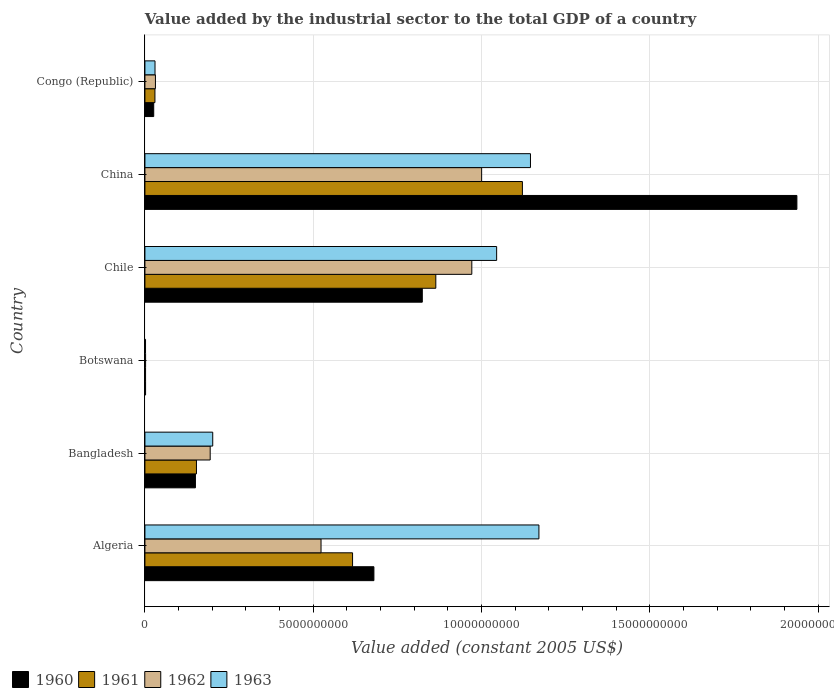How many groups of bars are there?
Provide a succinct answer. 6. Are the number of bars per tick equal to the number of legend labels?
Offer a terse response. Yes. How many bars are there on the 3rd tick from the bottom?
Ensure brevity in your answer.  4. What is the label of the 4th group of bars from the top?
Your answer should be very brief. Botswana. In how many cases, is the number of bars for a given country not equal to the number of legend labels?
Ensure brevity in your answer.  0. What is the value added by the industrial sector in 1962 in China?
Provide a succinct answer. 1.00e+1. Across all countries, what is the maximum value added by the industrial sector in 1962?
Keep it short and to the point. 1.00e+1. Across all countries, what is the minimum value added by the industrial sector in 1963?
Provide a succinct answer. 1.83e+07. In which country was the value added by the industrial sector in 1963 minimum?
Offer a terse response. Botswana. What is the total value added by the industrial sector in 1962 in the graph?
Your answer should be compact. 2.72e+1. What is the difference between the value added by the industrial sector in 1962 in Botswana and that in Chile?
Offer a very short reply. -9.69e+09. What is the difference between the value added by the industrial sector in 1961 in Bangladesh and the value added by the industrial sector in 1960 in Congo (Republic)?
Provide a succinct answer. 1.27e+09. What is the average value added by the industrial sector in 1961 per country?
Make the answer very short. 4.65e+09. What is the difference between the value added by the industrial sector in 1962 and value added by the industrial sector in 1961 in Chile?
Your response must be concise. 1.07e+09. In how many countries, is the value added by the industrial sector in 1961 greater than 15000000000 US$?
Give a very brief answer. 0. What is the ratio of the value added by the industrial sector in 1962 in Bangladesh to that in Congo (Republic)?
Provide a succinct answer. 6.21. Is the difference between the value added by the industrial sector in 1962 in Algeria and Bangladesh greater than the difference between the value added by the industrial sector in 1961 in Algeria and Bangladesh?
Offer a very short reply. No. What is the difference between the highest and the second highest value added by the industrial sector in 1963?
Your answer should be compact. 2.51e+08. What is the difference between the highest and the lowest value added by the industrial sector in 1963?
Ensure brevity in your answer.  1.17e+1. Is it the case that in every country, the sum of the value added by the industrial sector in 1961 and value added by the industrial sector in 1962 is greater than the sum of value added by the industrial sector in 1963 and value added by the industrial sector in 1960?
Your response must be concise. No. What does the 2nd bar from the top in Chile represents?
Give a very brief answer. 1962. Is it the case that in every country, the sum of the value added by the industrial sector in 1961 and value added by the industrial sector in 1960 is greater than the value added by the industrial sector in 1962?
Your response must be concise. Yes. How many bars are there?
Your answer should be very brief. 24. Are all the bars in the graph horizontal?
Keep it short and to the point. Yes. Does the graph contain any zero values?
Keep it short and to the point. No. Does the graph contain grids?
Your answer should be very brief. Yes. Where does the legend appear in the graph?
Give a very brief answer. Bottom left. What is the title of the graph?
Offer a terse response. Value added by the industrial sector to the total GDP of a country. What is the label or title of the X-axis?
Provide a succinct answer. Value added (constant 2005 US$). What is the label or title of the Y-axis?
Offer a terse response. Country. What is the Value added (constant 2005 US$) of 1960 in Algeria?
Provide a short and direct response. 6.80e+09. What is the Value added (constant 2005 US$) of 1961 in Algeria?
Your response must be concise. 6.17e+09. What is the Value added (constant 2005 US$) in 1962 in Algeria?
Provide a succinct answer. 5.23e+09. What is the Value added (constant 2005 US$) of 1963 in Algeria?
Your answer should be compact. 1.17e+1. What is the Value added (constant 2005 US$) of 1960 in Bangladesh?
Make the answer very short. 1.50e+09. What is the Value added (constant 2005 US$) of 1961 in Bangladesh?
Your answer should be very brief. 1.53e+09. What is the Value added (constant 2005 US$) of 1962 in Bangladesh?
Keep it short and to the point. 1.94e+09. What is the Value added (constant 2005 US$) in 1963 in Bangladesh?
Your answer should be compact. 2.01e+09. What is the Value added (constant 2005 US$) of 1960 in Botswana?
Keep it short and to the point. 1.96e+07. What is the Value added (constant 2005 US$) of 1961 in Botswana?
Your answer should be compact. 1.92e+07. What is the Value added (constant 2005 US$) of 1962 in Botswana?
Keep it short and to the point. 1.98e+07. What is the Value added (constant 2005 US$) of 1963 in Botswana?
Provide a short and direct response. 1.83e+07. What is the Value added (constant 2005 US$) of 1960 in Chile?
Give a very brief answer. 8.24e+09. What is the Value added (constant 2005 US$) in 1961 in Chile?
Your answer should be very brief. 8.64e+09. What is the Value added (constant 2005 US$) in 1962 in Chile?
Your response must be concise. 9.71e+09. What is the Value added (constant 2005 US$) in 1963 in Chile?
Your response must be concise. 1.04e+1. What is the Value added (constant 2005 US$) of 1960 in China?
Provide a short and direct response. 1.94e+1. What is the Value added (constant 2005 US$) of 1961 in China?
Your answer should be very brief. 1.12e+1. What is the Value added (constant 2005 US$) of 1962 in China?
Provide a succinct answer. 1.00e+1. What is the Value added (constant 2005 US$) in 1963 in China?
Make the answer very short. 1.15e+1. What is the Value added (constant 2005 US$) in 1960 in Congo (Republic)?
Ensure brevity in your answer.  2.61e+08. What is the Value added (constant 2005 US$) of 1961 in Congo (Republic)?
Offer a terse response. 2.98e+08. What is the Value added (constant 2005 US$) of 1962 in Congo (Republic)?
Your response must be concise. 3.12e+08. What is the Value added (constant 2005 US$) of 1963 in Congo (Republic)?
Give a very brief answer. 3.00e+08. Across all countries, what is the maximum Value added (constant 2005 US$) in 1960?
Provide a succinct answer. 1.94e+1. Across all countries, what is the maximum Value added (constant 2005 US$) of 1961?
Provide a short and direct response. 1.12e+1. Across all countries, what is the maximum Value added (constant 2005 US$) in 1962?
Your answer should be very brief. 1.00e+1. Across all countries, what is the maximum Value added (constant 2005 US$) of 1963?
Offer a terse response. 1.17e+1. Across all countries, what is the minimum Value added (constant 2005 US$) of 1960?
Your answer should be very brief. 1.96e+07. Across all countries, what is the minimum Value added (constant 2005 US$) of 1961?
Provide a short and direct response. 1.92e+07. Across all countries, what is the minimum Value added (constant 2005 US$) in 1962?
Your response must be concise. 1.98e+07. Across all countries, what is the minimum Value added (constant 2005 US$) in 1963?
Give a very brief answer. 1.83e+07. What is the total Value added (constant 2005 US$) in 1960 in the graph?
Keep it short and to the point. 3.62e+1. What is the total Value added (constant 2005 US$) in 1961 in the graph?
Offer a very short reply. 2.79e+1. What is the total Value added (constant 2005 US$) of 1962 in the graph?
Your response must be concise. 2.72e+1. What is the total Value added (constant 2005 US$) in 1963 in the graph?
Offer a terse response. 3.59e+1. What is the difference between the Value added (constant 2005 US$) of 1960 in Algeria and that in Bangladesh?
Give a very brief answer. 5.30e+09. What is the difference between the Value added (constant 2005 US$) of 1961 in Algeria and that in Bangladesh?
Your answer should be compact. 4.64e+09. What is the difference between the Value added (constant 2005 US$) of 1962 in Algeria and that in Bangladesh?
Make the answer very short. 3.29e+09. What is the difference between the Value added (constant 2005 US$) in 1963 in Algeria and that in Bangladesh?
Offer a very short reply. 9.69e+09. What is the difference between the Value added (constant 2005 US$) of 1960 in Algeria and that in Botswana?
Make the answer very short. 6.78e+09. What is the difference between the Value added (constant 2005 US$) of 1961 in Algeria and that in Botswana?
Offer a very short reply. 6.15e+09. What is the difference between the Value added (constant 2005 US$) of 1962 in Algeria and that in Botswana?
Give a very brief answer. 5.21e+09. What is the difference between the Value added (constant 2005 US$) in 1963 in Algeria and that in Botswana?
Provide a short and direct response. 1.17e+1. What is the difference between the Value added (constant 2005 US$) of 1960 in Algeria and that in Chile?
Provide a succinct answer. -1.44e+09. What is the difference between the Value added (constant 2005 US$) of 1961 in Algeria and that in Chile?
Keep it short and to the point. -2.47e+09. What is the difference between the Value added (constant 2005 US$) of 1962 in Algeria and that in Chile?
Ensure brevity in your answer.  -4.48e+09. What is the difference between the Value added (constant 2005 US$) in 1963 in Algeria and that in Chile?
Keep it short and to the point. 1.26e+09. What is the difference between the Value added (constant 2005 US$) in 1960 in Algeria and that in China?
Ensure brevity in your answer.  -1.26e+1. What is the difference between the Value added (constant 2005 US$) in 1961 in Algeria and that in China?
Your answer should be very brief. -5.05e+09. What is the difference between the Value added (constant 2005 US$) of 1962 in Algeria and that in China?
Make the answer very short. -4.77e+09. What is the difference between the Value added (constant 2005 US$) in 1963 in Algeria and that in China?
Offer a terse response. 2.51e+08. What is the difference between the Value added (constant 2005 US$) in 1960 in Algeria and that in Congo (Republic)?
Keep it short and to the point. 6.54e+09. What is the difference between the Value added (constant 2005 US$) in 1961 in Algeria and that in Congo (Republic)?
Your answer should be compact. 5.87e+09. What is the difference between the Value added (constant 2005 US$) of 1962 in Algeria and that in Congo (Republic)?
Make the answer very short. 4.92e+09. What is the difference between the Value added (constant 2005 US$) in 1963 in Algeria and that in Congo (Republic)?
Your answer should be very brief. 1.14e+1. What is the difference between the Value added (constant 2005 US$) of 1960 in Bangladesh and that in Botswana?
Give a very brief answer. 1.48e+09. What is the difference between the Value added (constant 2005 US$) of 1961 in Bangladesh and that in Botswana?
Provide a succinct answer. 1.51e+09. What is the difference between the Value added (constant 2005 US$) of 1962 in Bangladesh and that in Botswana?
Your answer should be very brief. 1.92e+09. What is the difference between the Value added (constant 2005 US$) of 1963 in Bangladesh and that in Botswana?
Provide a succinct answer. 2.00e+09. What is the difference between the Value added (constant 2005 US$) of 1960 in Bangladesh and that in Chile?
Your answer should be compact. -6.74e+09. What is the difference between the Value added (constant 2005 US$) in 1961 in Bangladesh and that in Chile?
Give a very brief answer. -7.11e+09. What is the difference between the Value added (constant 2005 US$) of 1962 in Bangladesh and that in Chile?
Give a very brief answer. -7.77e+09. What is the difference between the Value added (constant 2005 US$) in 1963 in Bangladesh and that in Chile?
Provide a short and direct response. -8.43e+09. What is the difference between the Value added (constant 2005 US$) in 1960 in Bangladesh and that in China?
Your answer should be very brief. -1.79e+1. What is the difference between the Value added (constant 2005 US$) in 1961 in Bangladesh and that in China?
Keep it short and to the point. -9.68e+09. What is the difference between the Value added (constant 2005 US$) of 1962 in Bangladesh and that in China?
Provide a succinct answer. -8.06e+09. What is the difference between the Value added (constant 2005 US$) in 1963 in Bangladesh and that in China?
Your answer should be compact. -9.44e+09. What is the difference between the Value added (constant 2005 US$) of 1960 in Bangladesh and that in Congo (Republic)?
Your answer should be very brief. 1.24e+09. What is the difference between the Value added (constant 2005 US$) in 1961 in Bangladesh and that in Congo (Republic)?
Your answer should be very brief. 1.23e+09. What is the difference between the Value added (constant 2005 US$) of 1962 in Bangladesh and that in Congo (Republic)?
Your answer should be very brief. 1.63e+09. What is the difference between the Value added (constant 2005 US$) in 1963 in Bangladesh and that in Congo (Republic)?
Give a very brief answer. 1.71e+09. What is the difference between the Value added (constant 2005 US$) of 1960 in Botswana and that in Chile?
Give a very brief answer. -8.22e+09. What is the difference between the Value added (constant 2005 US$) in 1961 in Botswana and that in Chile?
Your answer should be very brief. -8.62e+09. What is the difference between the Value added (constant 2005 US$) of 1962 in Botswana and that in Chile?
Offer a very short reply. -9.69e+09. What is the difference between the Value added (constant 2005 US$) of 1963 in Botswana and that in Chile?
Your response must be concise. -1.04e+1. What is the difference between the Value added (constant 2005 US$) of 1960 in Botswana and that in China?
Your response must be concise. -1.93e+1. What is the difference between the Value added (constant 2005 US$) of 1961 in Botswana and that in China?
Ensure brevity in your answer.  -1.12e+1. What is the difference between the Value added (constant 2005 US$) in 1962 in Botswana and that in China?
Keep it short and to the point. -9.98e+09. What is the difference between the Value added (constant 2005 US$) of 1963 in Botswana and that in China?
Provide a succinct answer. -1.14e+1. What is the difference between the Value added (constant 2005 US$) of 1960 in Botswana and that in Congo (Republic)?
Your answer should be very brief. -2.42e+08. What is the difference between the Value added (constant 2005 US$) of 1961 in Botswana and that in Congo (Republic)?
Your answer should be compact. -2.78e+08. What is the difference between the Value added (constant 2005 US$) in 1962 in Botswana and that in Congo (Republic)?
Provide a succinct answer. -2.93e+08. What is the difference between the Value added (constant 2005 US$) of 1963 in Botswana and that in Congo (Republic)?
Keep it short and to the point. -2.81e+08. What is the difference between the Value added (constant 2005 US$) of 1960 in Chile and that in China?
Ensure brevity in your answer.  -1.11e+1. What is the difference between the Value added (constant 2005 US$) of 1961 in Chile and that in China?
Offer a very short reply. -2.57e+09. What is the difference between the Value added (constant 2005 US$) in 1962 in Chile and that in China?
Your answer should be very brief. -2.92e+08. What is the difference between the Value added (constant 2005 US$) of 1963 in Chile and that in China?
Make the answer very short. -1.01e+09. What is the difference between the Value added (constant 2005 US$) in 1960 in Chile and that in Congo (Republic)?
Offer a very short reply. 7.98e+09. What is the difference between the Value added (constant 2005 US$) in 1961 in Chile and that in Congo (Republic)?
Give a very brief answer. 8.34e+09. What is the difference between the Value added (constant 2005 US$) in 1962 in Chile and that in Congo (Republic)?
Make the answer very short. 9.40e+09. What is the difference between the Value added (constant 2005 US$) of 1963 in Chile and that in Congo (Republic)?
Provide a short and direct response. 1.01e+1. What is the difference between the Value added (constant 2005 US$) of 1960 in China and that in Congo (Republic)?
Offer a very short reply. 1.91e+1. What is the difference between the Value added (constant 2005 US$) of 1961 in China and that in Congo (Republic)?
Make the answer very short. 1.09e+1. What is the difference between the Value added (constant 2005 US$) of 1962 in China and that in Congo (Republic)?
Provide a short and direct response. 9.69e+09. What is the difference between the Value added (constant 2005 US$) in 1963 in China and that in Congo (Republic)?
Provide a short and direct response. 1.12e+1. What is the difference between the Value added (constant 2005 US$) in 1960 in Algeria and the Value added (constant 2005 US$) in 1961 in Bangladesh?
Make the answer very short. 5.27e+09. What is the difference between the Value added (constant 2005 US$) of 1960 in Algeria and the Value added (constant 2005 US$) of 1962 in Bangladesh?
Keep it short and to the point. 4.86e+09. What is the difference between the Value added (constant 2005 US$) in 1960 in Algeria and the Value added (constant 2005 US$) in 1963 in Bangladesh?
Your answer should be compact. 4.79e+09. What is the difference between the Value added (constant 2005 US$) in 1961 in Algeria and the Value added (constant 2005 US$) in 1962 in Bangladesh?
Ensure brevity in your answer.  4.23e+09. What is the difference between the Value added (constant 2005 US$) of 1961 in Algeria and the Value added (constant 2005 US$) of 1963 in Bangladesh?
Offer a very short reply. 4.15e+09. What is the difference between the Value added (constant 2005 US$) in 1962 in Algeria and the Value added (constant 2005 US$) in 1963 in Bangladesh?
Offer a terse response. 3.22e+09. What is the difference between the Value added (constant 2005 US$) in 1960 in Algeria and the Value added (constant 2005 US$) in 1961 in Botswana?
Offer a terse response. 6.78e+09. What is the difference between the Value added (constant 2005 US$) in 1960 in Algeria and the Value added (constant 2005 US$) in 1962 in Botswana?
Give a very brief answer. 6.78e+09. What is the difference between the Value added (constant 2005 US$) of 1960 in Algeria and the Value added (constant 2005 US$) of 1963 in Botswana?
Ensure brevity in your answer.  6.78e+09. What is the difference between the Value added (constant 2005 US$) of 1961 in Algeria and the Value added (constant 2005 US$) of 1962 in Botswana?
Offer a terse response. 6.15e+09. What is the difference between the Value added (constant 2005 US$) in 1961 in Algeria and the Value added (constant 2005 US$) in 1963 in Botswana?
Your response must be concise. 6.15e+09. What is the difference between the Value added (constant 2005 US$) of 1962 in Algeria and the Value added (constant 2005 US$) of 1963 in Botswana?
Give a very brief answer. 5.21e+09. What is the difference between the Value added (constant 2005 US$) of 1960 in Algeria and the Value added (constant 2005 US$) of 1961 in Chile?
Keep it short and to the point. -1.84e+09. What is the difference between the Value added (constant 2005 US$) in 1960 in Algeria and the Value added (constant 2005 US$) in 1962 in Chile?
Offer a terse response. -2.91e+09. What is the difference between the Value added (constant 2005 US$) in 1960 in Algeria and the Value added (constant 2005 US$) in 1963 in Chile?
Keep it short and to the point. -3.65e+09. What is the difference between the Value added (constant 2005 US$) in 1961 in Algeria and the Value added (constant 2005 US$) in 1962 in Chile?
Your answer should be compact. -3.54e+09. What is the difference between the Value added (constant 2005 US$) in 1961 in Algeria and the Value added (constant 2005 US$) in 1963 in Chile?
Keep it short and to the point. -4.28e+09. What is the difference between the Value added (constant 2005 US$) of 1962 in Algeria and the Value added (constant 2005 US$) of 1963 in Chile?
Your answer should be compact. -5.22e+09. What is the difference between the Value added (constant 2005 US$) in 1960 in Algeria and the Value added (constant 2005 US$) in 1961 in China?
Provide a short and direct response. -4.41e+09. What is the difference between the Value added (constant 2005 US$) in 1960 in Algeria and the Value added (constant 2005 US$) in 1962 in China?
Your answer should be compact. -3.20e+09. What is the difference between the Value added (constant 2005 US$) in 1960 in Algeria and the Value added (constant 2005 US$) in 1963 in China?
Your answer should be very brief. -4.65e+09. What is the difference between the Value added (constant 2005 US$) in 1961 in Algeria and the Value added (constant 2005 US$) in 1962 in China?
Your answer should be compact. -3.83e+09. What is the difference between the Value added (constant 2005 US$) in 1961 in Algeria and the Value added (constant 2005 US$) in 1963 in China?
Keep it short and to the point. -5.28e+09. What is the difference between the Value added (constant 2005 US$) in 1962 in Algeria and the Value added (constant 2005 US$) in 1963 in China?
Provide a succinct answer. -6.22e+09. What is the difference between the Value added (constant 2005 US$) in 1960 in Algeria and the Value added (constant 2005 US$) in 1961 in Congo (Republic)?
Your answer should be very brief. 6.50e+09. What is the difference between the Value added (constant 2005 US$) of 1960 in Algeria and the Value added (constant 2005 US$) of 1962 in Congo (Republic)?
Give a very brief answer. 6.49e+09. What is the difference between the Value added (constant 2005 US$) in 1960 in Algeria and the Value added (constant 2005 US$) in 1963 in Congo (Republic)?
Make the answer very short. 6.50e+09. What is the difference between the Value added (constant 2005 US$) of 1961 in Algeria and the Value added (constant 2005 US$) of 1962 in Congo (Republic)?
Ensure brevity in your answer.  5.86e+09. What is the difference between the Value added (constant 2005 US$) in 1961 in Algeria and the Value added (constant 2005 US$) in 1963 in Congo (Republic)?
Your response must be concise. 5.87e+09. What is the difference between the Value added (constant 2005 US$) in 1962 in Algeria and the Value added (constant 2005 US$) in 1963 in Congo (Republic)?
Make the answer very short. 4.93e+09. What is the difference between the Value added (constant 2005 US$) in 1960 in Bangladesh and the Value added (constant 2005 US$) in 1961 in Botswana?
Keep it short and to the point. 1.48e+09. What is the difference between the Value added (constant 2005 US$) of 1960 in Bangladesh and the Value added (constant 2005 US$) of 1962 in Botswana?
Provide a short and direct response. 1.48e+09. What is the difference between the Value added (constant 2005 US$) of 1960 in Bangladesh and the Value added (constant 2005 US$) of 1963 in Botswana?
Ensure brevity in your answer.  1.48e+09. What is the difference between the Value added (constant 2005 US$) in 1961 in Bangladesh and the Value added (constant 2005 US$) in 1962 in Botswana?
Your answer should be very brief. 1.51e+09. What is the difference between the Value added (constant 2005 US$) of 1961 in Bangladesh and the Value added (constant 2005 US$) of 1963 in Botswana?
Keep it short and to the point. 1.51e+09. What is the difference between the Value added (constant 2005 US$) in 1962 in Bangladesh and the Value added (constant 2005 US$) in 1963 in Botswana?
Provide a short and direct response. 1.92e+09. What is the difference between the Value added (constant 2005 US$) in 1960 in Bangladesh and the Value added (constant 2005 US$) in 1961 in Chile?
Provide a succinct answer. -7.14e+09. What is the difference between the Value added (constant 2005 US$) of 1960 in Bangladesh and the Value added (constant 2005 US$) of 1962 in Chile?
Provide a succinct answer. -8.21e+09. What is the difference between the Value added (constant 2005 US$) in 1960 in Bangladesh and the Value added (constant 2005 US$) in 1963 in Chile?
Your answer should be very brief. -8.95e+09. What is the difference between the Value added (constant 2005 US$) of 1961 in Bangladesh and the Value added (constant 2005 US$) of 1962 in Chile?
Offer a terse response. -8.18e+09. What is the difference between the Value added (constant 2005 US$) in 1961 in Bangladesh and the Value added (constant 2005 US$) in 1963 in Chile?
Give a very brief answer. -8.92e+09. What is the difference between the Value added (constant 2005 US$) in 1962 in Bangladesh and the Value added (constant 2005 US$) in 1963 in Chile?
Offer a very short reply. -8.51e+09. What is the difference between the Value added (constant 2005 US$) in 1960 in Bangladesh and the Value added (constant 2005 US$) in 1961 in China?
Your answer should be very brief. -9.71e+09. What is the difference between the Value added (constant 2005 US$) of 1960 in Bangladesh and the Value added (constant 2005 US$) of 1962 in China?
Your answer should be very brief. -8.50e+09. What is the difference between the Value added (constant 2005 US$) in 1960 in Bangladesh and the Value added (constant 2005 US$) in 1963 in China?
Ensure brevity in your answer.  -9.95e+09. What is the difference between the Value added (constant 2005 US$) in 1961 in Bangladesh and the Value added (constant 2005 US$) in 1962 in China?
Provide a short and direct response. -8.47e+09. What is the difference between the Value added (constant 2005 US$) of 1961 in Bangladesh and the Value added (constant 2005 US$) of 1963 in China?
Provide a succinct answer. -9.92e+09. What is the difference between the Value added (constant 2005 US$) in 1962 in Bangladesh and the Value added (constant 2005 US$) in 1963 in China?
Give a very brief answer. -9.51e+09. What is the difference between the Value added (constant 2005 US$) in 1960 in Bangladesh and the Value added (constant 2005 US$) in 1961 in Congo (Republic)?
Ensure brevity in your answer.  1.20e+09. What is the difference between the Value added (constant 2005 US$) in 1960 in Bangladesh and the Value added (constant 2005 US$) in 1962 in Congo (Republic)?
Your answer should be very brief. 1.19e+09. What is the difference between the Value added (constant 2005 US$) of 1960 in Bangladesh and the Value added (constant 2005 US$) of 1963 in Congo (Republic)?
Provide a short and direct response. 1.20e+09. What is the difference between the Value added (constant 2005 US$) in 1961 in Bangladesh and the Value added (constant 2005 US$) in 1962 in Congo (Republic)?
Your response must be concise. 1.22e+09. What is the difference between the Value added (constant 2005 US$) of 1961 in Bangladesh and the Value added (constant 2005 US$) of 1963 in Congo (Republic)?
Make the answer very short. 1.23e+09. What is the difference between the Value added (constant 2005 US$) of 1962 in Bangladesh and the Value added (constant 2005 US$) of 1963 in Congo (Republic)?
Offer a very short reply. 1.64e+09. What is the difference between the Value added (constant 2005 US$) of 1960 in Botswana and the Value added (constant 2005 US$) of 1961 in Chile?
Your response must be concise. -8.62e+09. What is the difference between the Value added (constant 2005 US$) of 1960 in Botswana and the Value added (constant 2005 US$) of 1962 in Chile?
Provide a succinct answer. -9.69e+09. What is the difference between the Value added (constant 2005 US$) in 1960 in Botswana and the Value added (constant 2005 US$) in 1963 in Chile?
Your response must be concise. -1.04e+1. What is the difference between the Value added (constant 2005 US$) in 1961 in Botswana and the Value added (constant 2005 US$) in 1962 in Chile?
Your response must be concise. -9.69e+09. What is the difference between the Value added (constant 2005 US$) in 1961 in Botswana and the Value added (constant 2005 US$) in 1963 in Chile?
Keep it short and to the point. -1.04e+1. What is the difference between the Value added (constant 2005 US$) of 1962 in Botswana and the Value added (constant 2005 US$) of 1963 in Chile?
Offer a terse response. -1.04e+1. What is the difference between the Value added (constant 2005 US$) in 1960 in Botswana and the Value added (constant 2005 US$) in 1961 in China?
Offer a very short reply. -1.12e+1. What is the difference between the Value added (constant 2005 US$) of 1960 in Botswana and the Value added (constant 2005 US$) of 1962 in China?
Provide a short and direct response. -9.98e+09. What is the difference between the Value added (constant 2005 US$) of 1960 in Botswana and the Value added (constant 2005 US$) of 1963 in China?
Offer a very short reply. -1.14e+1. What is the difference between the Value added (constant 2005 US$) of 1961 in Botswana and the Value added (constant 2005 US$) of 1962 in China?
Provide a succinct answer. -9.98e+09. What is the difference between the Value added (constant 2005 US$) in 1961 in Botswana and the Value added (constant 2005 US$) in 1963 in China?
Ensure brevity in your answer.  -1.14e+1. What is the difference between the Value added (constant 2005 US$) of 1962 in Botswana and the Value added (constant 2005 US$) of 1963 in China?
Offer a terse response. -1.14e+1. What is the difference between the Value added (constant 2005 US$) in 1960 in Botswana and the Value added (constant 2005 US$) in 1961 in Congo (Republic)?
Ensure brevity in your answer.  -2.78e+08. What is the difference between the Value added (constant 2005 US$) in 1960 in Botswana and the Value added (constant 2005 US$) in 1962 in Congo (Republic)?
Offer a terse response. -2.93e+08. What is the difference between the Value added (constant 2005 US$) in 1960 in Botswana and the Value added (constant 2005 US$) in 1963 in Congo (Republic)?
Keep it short and to the point. -2.80e+08. What is the difference between the Value added (constant 2005 US$) of 1961 in Botswana and the Value added (constant 2005 US$) of 1962 in Congo (Republic)?
Your response must be concise. -2.93e+08. What is the difference between the Value added (constant 2005 US$) in 1961 in Botswana and the Value added (constant 2005 US$) in 1963 in Congo (Republic)?
Your answer should be very brief. -2.81e+08. What is the difference between the Value added (constant 2005 US$) of 1962 in Botswana and the Value added (constant 2005 US$) of 1963 in Congo (Republic)?
Offer a very short reply. -2.80e+08. What is the difference between the Value added (constant 2005 US$) in 1960 in Chile and the Value added (constant 2005 US$) in 1961 in China?
Offer a very short reply. -2.97e+09. What is the difference between the Value added (constant 2005 US$) of 1960 in Chile and the Value added (constant 2005 US$) of 1962 in China?
Your answer should be very brief. -1.76e+09. What is the difference between the Value added (constant 2005 US$) of 1960 in Chile and the Value added (constant 2005 US$) of 1963 in China?
Make the answer very short. -3.21e+09. What is the difference between the Value added (constant 2005 US$) of 1961 in Chile and the Value added (constant 2005 US$) of 1962 in China?
Ensure brevity in your answer.  -1.36e+09. What is the difference between the Value added (constant 2005 US$) in 1961 in Chile and the Value added (constant 2005 US$) in 1963 in China?
Your answer should be very brief. -2.81e+09. What is the difference between the Value added (constant 2005 US$) of 1962 in Chile and the Value added (constant 2005 US$) of 1963 in China?
Give a very brief answer. -1.74e+09. What is the difference between the Value added (constant 2005 US$) of 1960 in Chile and the Value added (constant 2005 US$) of 1961 in Congo (Republic)?
Your answer should be compact. 7.94e+09. What is the difference between the Value added (constant 2005 US$) in 1960 in Chile and the Value added (constant 2005 US$) in 1962 in Congo (Republic)?
Your answer should be compact. 7.93e+09. What is the difference between the Value added (constant 2005 US$) of 1960 in Chile and the Value added (constant 2005 US$) of 1963 in Congo (Republic)?
Provide a succinct answer. 7.94e+09. What is the difference between the Value added (constant 2005 US$) of 1961 in Chile and the Value added (constant 2005 US$) of 1962 in Congo (Republic)?
Offer a very short reply. 8.33e+09. What is the difference between the Value added (constant 2005 US$) in 1961 in Chile and the Value added (constant 2005 US$) in 1963 in Congo (Republic)?
Ensure brevity in your answer.  8.34e+09. What is the difference between the Value added (constant 2005 US$) in 1962 in Chile and the Value added (constant 2005 US$) in 1963 in Congo (Republic)?
Your answer should be very brief. 9.41e+09. What is the difference between the Value added (constant 2005 US$) in 1960 in China and the Value added (constant 2005 US$) in 1961 in Congo (Republic)?
Your answer should be compact. 1.91e+1. What is the difference between the Value added (constant 2005 US$) of 1960 in China and the Value added (constant 2005 US$) of 1962 in Congo (Republic)?
Your answer should be very brief. 1.91e+1. What is the difference between the Value added (constant 2005 US$) in 1960 in China and the Value added (constant 2005 US$) in 1963 in Congo (Republic)?
Make the answer very short. 1.91e+1. What is the difference between the Value added (constant 2005 US$) in 1961 in China and the Value added (constant 2005 US$) in 1962 in Congo (Republic)?
Your answer should be very brief. 1.09e+1. What is the difference between the Value added (constant 2005 US$) in 1961 in China and the Value added (constant 2005 US$) in 1963 in Congo (Republic)?
Ensure brevity in your answer.  1.09e+1. What is the difference between the Value added (constant 2005 US$) of 1962 in China and the Value added (constant 2005 US$) of 1963 in Congo (Republic)?
Provide a short and direct response. 9.70e+09. What is the average Value added (constant 2005 US$) of 1960 per country?
Offer a very short reply. 6.03e+09. What is the average Value added (constant 2005 US$) of 1961 per country?
Keep it short and to the point. 4.65e+09. What is the average Value added (constant 2005 US$) of 1962 per country?
Your response must be concise. 4.54e+09. What is the average Value added (constant 2005 US$) of 1963 per country?
Provide a short and direct response. 5.99e+09. What is the difference between the Value added (constant 2005 US$) in 1960 and Value added (constant 2005 US$) in 1961 in Algeria?
Keep it short and to the point. 6.34e+08. What is the difference between the Value added (constant 2005 US$) of 1960 and Value added (constant 2005 US$) of 1962 in Algeria?
Your response must be concise. 1.57e+09. What is the difference between the Value added (constant 2005 US$) of 1960 and Value added (constant 2005 US$) of 1963 in Algeria?
Keep it short and to the point. -4.90e+09. What is the difference between the Value added (constant 2005 US$) of 1961 and Value added (constant 2005 US$) of 1962 in Algeria?
Provide a short and direct response. 9.37e+08. What is the difference between the Value added (constant 2005 US$) in 1961 and Value added (constant 2005 US$) in 1963 in Algeria?
Offer a terse response. -5.54e+09. What is the difference between the Value added (constant 2005 US$) of 1962 and Value added (constant 2005 US$) of 1963 in Algeria?
Offer a terse response. -6.47e+09. What is the difference between the Value added (constant 2005 US$) in 1960 and Value added (constant 2005 US$) in 1961 in Bangladesh?
Give a very brief answer. -3.05e+07. What is the difference between the Value added (constant 2005 US$) of 1960 and Value added (constant 2005 US$) of 1962 in Bangladesh?
Offer a very short reply. -4.38e+08. What is the difference between the Value added (constant 2005 US$) in 1960 and Value added (constant 2005 US$) in 1963 in Bangladesh?
Offer a very short reply. -5.14e+08. What is the difference between the Value added (constant 2005 US$) of 1961 and Value added (constant 2005 US$) of 1962 in Bangladesh?
Ensure brevity in your answer.  -4.08e+08. What is the difference between the Value added (constant 2005 US$) of 1961 and Value added (constant 2005 US$) of 1963 in Bangladesh?
Ensure brevity in your answer.  -4.84e+08. What is the difference between the Value added (constant 2005 US$) of 1962 and Value added (constant 2005 US$) of 1963 in Bangladesh?
Your response must be concise. -7.60e+07. What is the difference between the Value added (constant 2005 US$) in 1960 and Value added (constant 2005 US$) in 1961 in Botswana?
Provide a short and direct response. 4.24e+05. What is the difference between the Value added (constant 2005 US$) of 1960 and Value added (constant 2005 US$) of 1962 in Botswana?
Your response must be concise. -2.12e+05. What is the difference between the Value added (constant 2005 US$) of 1960 and Value added (constant 2005 US$) of 1963 in Botswana?
Make the answer very short. 1.27e+06. What is the difference between the Value added (constant 2005 US$) in 1961 and Value added (constant 2005 US$) in 1962 in Botswana?
Your response must be concise. -6.36e+05. What is the difference between the Value added (constant 2005 US$) in 1961 and Value added (constant 2005 US$) in 1963 in Botswana?
Provide a succinct answer. 8.48e+05. What is the difference between the Value added (constant 2005 US$) of 1962 and Value added (constant 2005 US$) of 1963 in Botswana?
Your response must be concise. 1.48e+06. What is the difference between the Value added (constant 2005 US$) of 1960 and Value added (constant 2005 US$) of 1961 in Chile?
Make the answer very short. -4.01e+08. What is the difference between the Value added (constant 2005 US$) in 1960 and Value added (constant 2005 US$) in 1962 in Chile?
Ensure brevity in your answer.  -1.47e+09. What is the difference between the Value added (constant 2005 US$) in 1960 and Value added (constant 2005 US$) in 1963 in Chile?
Your response must be concise. -2.21e+09. What is the difference between the Value added (constant 2005 US$) of 1961 and Value added (constant 2005 US$) of 1962 in Chile?
Offer a terse response. -1.07e+09. What is the difference between the Value added (constant 2005 US$) in 1961 and Value added (constant 2005 US$) in 1963 in Chile?
Ensure brevity in your answer.  -1.81e+09. What is the difference between the Value added (constant 2005 US$) of 1962 and Value added (constant 2005 US$) of 1963 in Chile?
Ensure brevity in your answer.  -7.37e+08. What is the difference between the Value added (constant 2005 US$) of 1960 and Value added (constant 2005 US$) of 1961 in China?
Provide a short and direct response. 8.15e+09. What is the difference between the Value added (constant 2005 US$) in 1960 and Value added (constant 2005 US$) in 1962 in China?
Give a very brief answer. 9.36e+09. What is the difference between the Value added (constant 2005 US$) of 1960 and Value added (constant 2005 US$) of 1963 in China?
Offer a terse response. 7.91e+09. What is the difference between the Value added (constant 2005 US$) in 1961 and Value added (constant 2005 US$) in 1962 in China?
Make the answer very short. 1.21e+09. What is the difference between the Value added (constant 2005 US$) of 1961 and Value added (constant 2005 US$) of 1963 in China?
Keep it short and to the point. -2.39e+08. What is the difference between the Value added (constant 2005 US$) in 1962 and Value added (constant 2005 US$) in 1963 in China?
Offer a very short reply. -1.45e+09. What is the difference between the Value added (constant 2005 US$) in 1960 and Value added (constant 2005 US$) in 1961 in Congo (Republic)?
Your response must be concise. -3.63e+07. What is the difference between the Value added (constant 2005 US$) in 1960 and Value added (constant 2005 US$) in 1962 in Congo (Republic)?
Your answer should be compact. -5.10e+07. What is the difference between the Value added (constant 2005 US$) of 1960 and Value added (constant 2005 US$) of 1963 in Congo (Republic)?
Provide a succinct answer. -3.84e+07. What is the difference between the Value added (constant 2005 US$) in 1961 and Value added (constant 2005 US$) in 1962 in Congo (Republic)?
Make the answer very short. -1.47e+07. What is the difference between the Value added (constant 2005 US$) in 1961 and Value added (constant 2005 US$) in 1963 in Congo (Republic)?
Offer a terse response. -2.10e+06. What is the difference between the Value added (constant 2005 US$) of 1962 and Value added (constant 2005 US$) of 1963 in Congo (Republic)?
Provide a succinct answer. 1.26e+07. What is the ratio of the Value added (constant 2005 US$) in 1960 in Algeria to that in Bangladesh?
Provide a succinct answer. 4.53. What is the ratio of the Value added (constant 2005 US$) of 1961 in Algeria to that in Bangladesh?
Ensure brevity in your answer.  4.03. What is the ratio of the Value added (constant 2005 US$) of 1962 in Algeria to that in Bangladesh?
Make the answer very short. 2.7. What is the ratio of the Value added (constant 2005 US$) of 1963 in Algeria to that in Bangladesh?
Provide a succinct answer. 5.81. What is the ratio of the Value added (constant 2005 US$) of 1960 in Algeria to that in Botswana?
Provide a succinct answer. 346.79. What is the ratio of the Value added (constant 2005 US$) in 1961 in Algeria to that in Botswana?
Ensure brevity in your answer.  321.41. What is the ratio of the Value added (constant 2005 US$) of 1962 in Algeria to that in Botswana?
Give a very brief answer. 263.85. What is the ratio of the Value added (constant 2005 US$) in 1963 in Algeria to that in Botswana?
Your answer should be compact. 638.08. What is the ratio of the Value added (constant 2005 US$) of 1960 in Algeria to that in Chile?
Your answer should be compact. 0.83. What is the ratio of the Value added (constant 2005 US$) of 1961 in Algeria to that in Chile?
Your answer should be compact. 0.71. What is the ratio of the Value added (constant 2005 US$) of 1962 in Algeria to that in Chile?
Make the answer very short. 0.54. What is the ratio of the Value added (constant 2005 US$) of 1963 in Algeria to that in Chile?
Give a very brief answer. 1.12. What is the ratio of the Value added (constant 2005 US$) in 1960 in Algeria to that in China?
Provide a succinct answer. 0.35. What is the ratio of the Value added (constant 2005 US$) in 1961 in Algeria to that in China?
Provide a succinct answer. 0.55. What is the ratio of the Value added (constant 2005 US$) in 1962 in Algeria to that in China?
Keep it short and to the point. 0.52. What is the ratio of the Value added (constant 2005 US$) of 1963 in Algeria to that in China?
Keep it short and to the point. 1.02. What is the ratio of the Value added (constant 2005 US$) of 1960 in Algeria to that in Congo (Republic)?
Give a very brief answer. 26.02. What is the ratio of the Value added (constant 2005 US$) in 1961 in Algeria to that in Congo (Republic)?
Give a very brief answer. 20.72. What is the ratio of the Value added (constant 2005 US$) of 1962 in Algeria to that in Congo (Republic)?
Keep it short and to the point. 16.75. What is the ratio of the Value added (constant 2005 US$) in 1963 in Algeria to that in Congo (Republic)?
Your answer should be compact. 39.05. What is the ratio of the Value added (constant 2005 US$) in 1960 in Bangladesh to that in Botswana?
Offer a very short reply. 76.48. What is the ratio of the Value added (constant 2005 US$) in 1961 in Bangladesh to that in Botswana?
Your answer should be very brief. 79.76. What is the ratio of the Value added (constant 2005 US$) of 1962 in Bangladesh to that in Botswana?
Keep it short and to the point. 97.78. What is the ratio of the Value added (constant 2005 US$) of 1963 in Bangladesh to that in Botswana?
Give a very brief answer. 109.83. What is the ratio of the Value added (constant 2005 US$) in 1960 in Bangladesh to that in Chile?
Offer a very short reply. 0.18. What is the ratio of the Value added (constant 2005 US$) in 1961 in Bangladesh to that in Chile?
Offer a very short reply. 0.18. What is the ratio of the Value added (constant 2005 US$) in 1962 in Bangladesh to that in Chile?
Your answer should be compact. 0.2. What is the ratio of the Value added (constant 2005 US$) in 1963 in Bangladesh to that in Chile?
Your response must be concise. 0.19. What is the ratio of the Value added (constant 2005 US$) in 1960 in Bangladesh to that in China?
Make the answer very short. 0.08. What is the ratio of the Value added (constant 2005 US$) of 1961 in Bangladesh to that in China?
Ensure brevity in your answer.  0.14. What is the ratio of the Value added (constant 2005 US$) in 1962 in Bangladesh to that in China?
Your answer should be compact. 0.19. What is the ratio of the Value added (constant 2005 US$) of 1963 in Bangladesh to that in China?
Your response must be concise. 0.18. What is the ratio of the Value added (constant 2005 US$) of 1960 in Bangladesh to that in Congo (Republic)?
Provide a short and direct response. 5.74. What is the ratio of the Value added (constant 2005 US$) in 1961 in Bangladesh to that in Congo (Republic)?
Your answer should be compact. 5.14. What is the ratio of the Value added (constant 2005 US$) of 1962 in Bangladesh to that in Congo (Republic)?
Your answer should be compact. 6.21. What is the ratio of the Value added (constant 2005 US$) in 1963 in Bangladesh to that in Congo (Republic)?
Provide a succinct answer. 6.72. What is the ratio of the Value added (constant 2005 US$) in 1960 in Botswana to that in Chile?
Your answer should be very brief. 0. What is the ratio of the Value added (constant 2005 US$) of 1961 in Botswana to that in Chile?
Give a very brief answer. 0. What is the ratio of the Value added (constant 2005 US$) of 1962 in Botswana to that in Chile?
Give a very brief answer. 0. What is the ratio of the Value added (constant 2005 US$) in 1963 in Botswana to that in Chile?
Ensure brevity in your answer.  0. What is the ratio of the Value added (constant 2005 US$) of 1960 in Botswana to that in China?
Your answer should be compact. 0. What is the ratio of the Value added (constant 2005 US$) of 1961 in Botswana to that in China?
Provide a succinct answer. 0. What is the ratio of the Value added (constant 2005 US$) of 1962 in Botswana to that in China?
Your response must be concise. 0. What is the ratio of the Value added (constant 2005 US$) of 1963 in Botswana to that in China?
Make the answer very short. 0. What is the ratio of the Value added (constant 2005 US$) of 1960 in Botswana to that in Congo (Republic)?
Ensure brevity in your answer.  0.07. What is the ratio of the Value added (constant 2005 US$) of 1961 in Botswana to that in Congo (Republic)?
Ensure brevity in your answer.  0.06. What is the ratio of the Value added (constant 2005 US$) of 1962 in Botswana to that in Congo (Republic)?
Ensure brevity in your answer.  0.06. What is the ratio of the Value added (constant 2005 US$) of 1963 in Botswana to that in Congo (Republic)?
Give a very brief answer. 0.06. What is the ratio of the Value added (constant 2005 US$) of 1960 in Chile to that in China?
Provide a succinct answer. 0.43. What is the ratio of the Value added (constant 2005 US$) in 1961 in Chile to that in China?
Give a very brief answer. 0.77. What is the ratio of the Value added (constant 2005 US$) in 1962 in Chile to that in China?
Your answer should be compact. 0.97. What is the ratio of the Value added (constant 2005 US$) in 1963 in Chile to that in China?
Keep it short and to the point. 0.91. What is the ratio of the Value added (constant 2005 US$) in 1960 in Chile to that in Congo (Republic)?
Your answer should be compact. 31.52. What is the ratio of the Value added (constant 2005 US$) in 1961 in Chile to that in Congo (Republic)?
Offer a terse response. 29.03. What is the ratio of the Value added (constant 2005 US$) of 1962 in Chile to that in Congo (Republic)?
Your answer should be compact. 31.09. What is the ratio of the Value added (constant 2005 US$) of 1963 in Chile to that in Congo (Republic)?
Your answer should be compact. 34.85. What is the ratio of the Value added (constant 2005 US$) in 1960 in China to that in Congo (Republic)?
Your answer should be compact. 74.09. What is the ratio of the Value added (constant 2005 US$) in 1961 in China to that in Congo (Republic)?
Keep it short and to the point. 37.67. What is the ratio of the Value added (constant 2005 US$) of 1962 in China to that in Congo (Republic)?
Your response must be concise. 32.02. What is the ratio of the Value added (constant 2005 US$) of 1963 in China to that in Congo (Republic)?
Your response must be concise. 38.21. What is the difference between the highest and the second highest Value added (constant 2005 US$) in 1960?
Make the answer very short. 1.11e+1. What is the difference between the highest and the second highest Value added (constant 2005 US$) of 1961?
Offer a very short reply. 2.57e+09. What is the difference between the highest and the second highest Value added (constant 2005 US$) of 1962?
Offer a very short reply. 2.92e+08. What is the difference between the highest and the second highest Value added (constant 2005 US$) of 1963?
Your answer should be very brief. 2.51e+08. What is the difference between the highest and the lowest Value added (constant 2005 US$) of 1960?
Ensure brevity in your answer.  1.93e+1. What is the difference between the highest and the lowest Value added (constant 2005 US$) in 1961?
Your answer should be very brief. 1.12e+1. What is the difference between the highest and the lowest Value added (constant 2005 US$) of 1962?
Your answer should be very brief. 9.98e+09. What is the difference between the highest and the lowest Value added (constant 2005 US$) in 1963?
Offer a very short reply. 1.17e+1. 